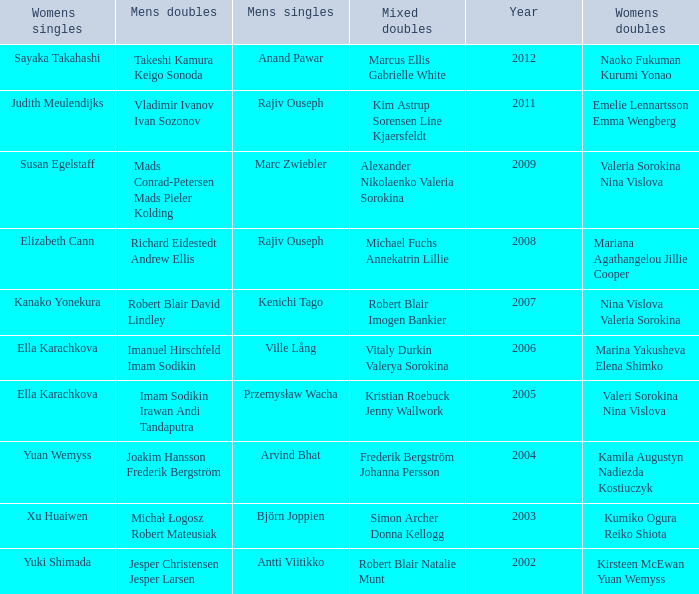Name the men's singles of marina yakusheva elena shimko Ville Lång. Could you help me parse every detail presented in this table? {'header': ['Womens singles', 'Mens doubles', 'Mens singles', 'Mixed doubles', 'Year', 'Womens doubles'], 'rows': [['Sayaka Takahashi', 'Takeshi Kamura Keigo Sonoda', 'Anand Pawar', 'Marcus Ellis Gabrielle White', '2012', 'Naoko Fukuman Kurumi Yonao'], ['Judith Meulendijks', 'Vladimir Ivanov Ivan Sozonov', 'Rajiv Ouseph', 'Kim Astrup Sorensen Line Kjaersfeldt', '2011', 'Emelie Lennartsson Emma Wengberg'], ['Susan Egelstaff', 'Mads Conrad-Petersen Mads Pieler Kolding', 'Marc Zwiebler', 'Alexander Nikolaenko Valeria Sorokina', '2009', 'Valeria Sorokina Nina Vislova'], ['Elizabeth Cann', 'Richard Eidestedt Andrew Ellis', 'Rajiv Ouseph', 'Michael Fuchs Annekatrin Lillie', '2008', 'Mariana Agathangelou Jillie Cooper'], ['Kanako Yonekura', 'Robert Blair David Lindley', 'Kenichi Tago', 'Robert Blair Imogen Bankier', '2007', 'Nina Vislova Valeria Sorokina'], ['Ella Karachkova', 'Imanuel Hirschfeld Imam Sodikin', 'Ville Lång', 'Vitaly Durkin Valerya Sorokina', '2006', 'Marina Yakusheva Elena Shimko'], ['Ella Karachkova', 'Imam Sodikin Irawan Andi Tandaputra', 'Przemysław Wacha', 'Kristian Roebuck Jenny Wallwork', '2005', 'Valeri Sorokina Nina Vislova'], ['Yuan Wemyss', 'Joakim Hansson Frederik Bergström', 'Arvind Bhat', 'Frederik Bergström Johanna Persson', '2004', 'Kamila Augustyn Nadiezda Kostiuczyk'], ['Xu Huaiwen', 'Michał Łogosz Robert Mateusiak', 'Björn Joppien', 'Simon Archer Donna Kellogg', '2003', 'Kumiko Ogura Reiko Shiota'], ['Yuki Shimada', 'Jesper Christensen Jesper Larsen', 'Antti Viitikko', 'Robert Blair Natalie Munt', '2002', 'Kirsteen McEwan Yuan Wemyss']]} 